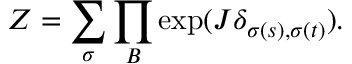Convert formula to latex. <formula><loc_0><loc_0><loc_500><loc_500>Z = \sum _ { \sigma } \prod _ { B } \exp ( J \delta _ { \sigma ( s ) , \sigma ( t ) } ) .</formula> 